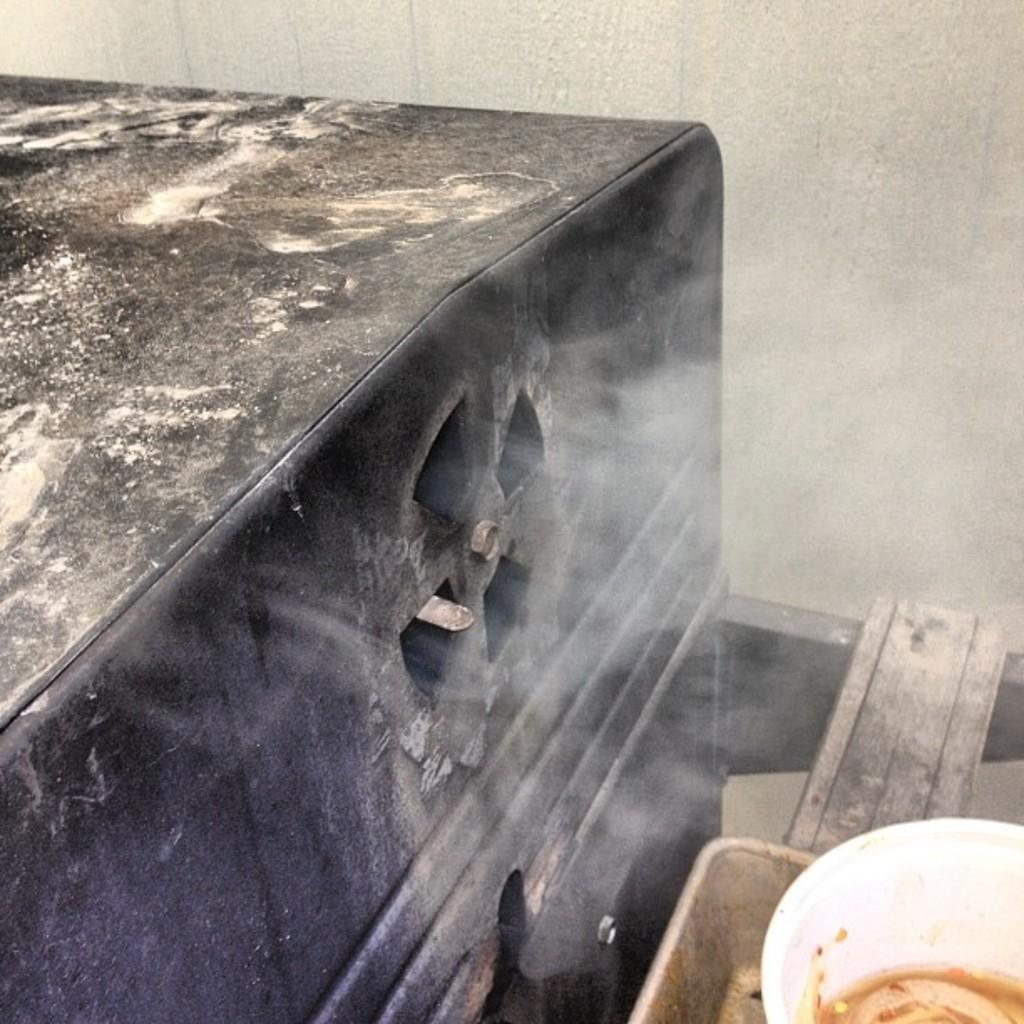What is the color of the object in the image? The object in the image is black. What can be seen in the image besides the black object? There is a bowl and a wooden object visible in the image. What is the background of the image? There is a wall in the background of the image. What type of meat is being cooked by the partner in the image? There is no meat or partner present in the image. What is the opinion of the person in the image about the wooden object? There is no person present in the image to express an opinion about the wooden object. 